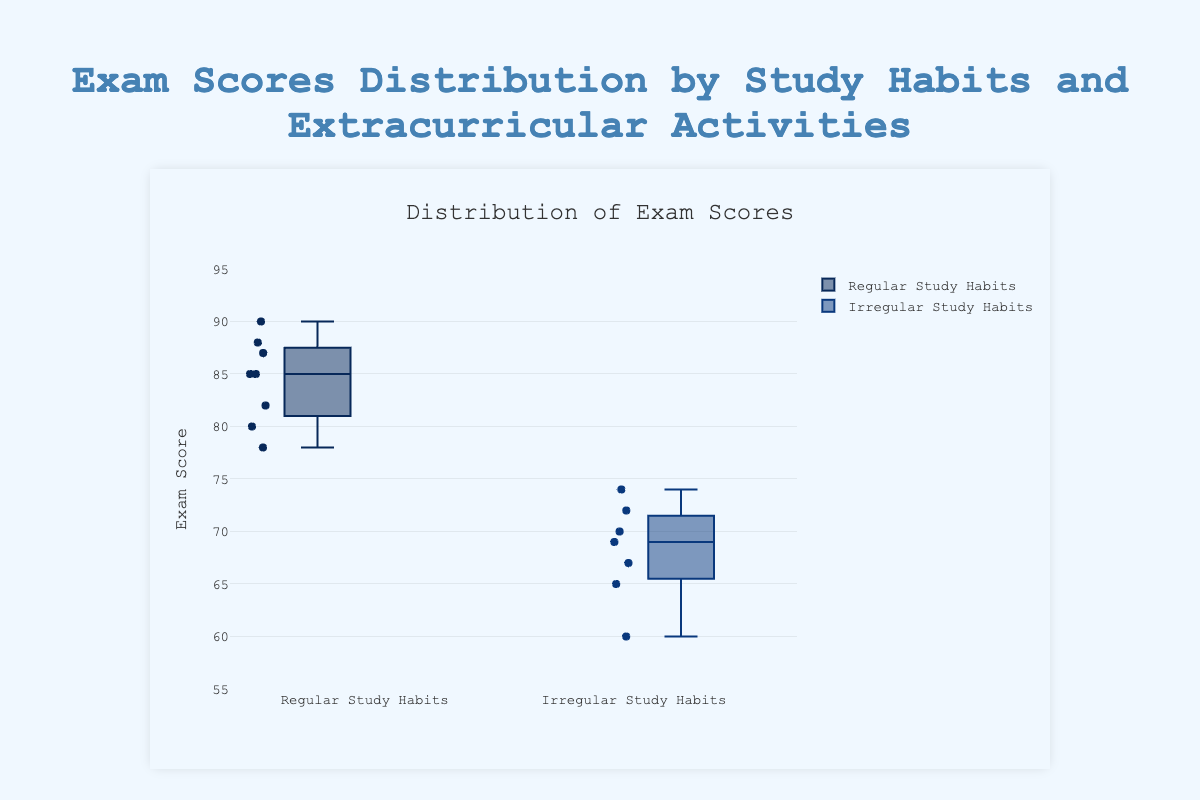What is the title of the box plot? The title is located at the top center of the plot and provides a summary description of what the box plot represents. Here, it reads "Distribution of Exam Scores."
Answer: Distribution of Exam Scores What are the categories on the x-axis? The x-axis categories are the levels of the grouping variable, which in this case are the two types of study habits: "Regular Study Habits" and "Irregular Study Habits."
Answer: Regular Study Habits, Irregular Study Habits What is the range of exam scores represented on the y-axis? The y-axis shows a numerical range indicating exam scores. It spans from approximately 55 to 95, as outlined by the axis labels and tick marks within this interval.
Answer: 55 to 95 Which study habit category has the higher median score? The median score for each category is marked by the line inside the box. By comparing the median lines within the boxes for both categories, the median for "Regular Study Habits" is higher than "Irregular Study Habits."
Answer: Regular Study Habits What is the interquartile range (IQR) for students with irregular study habits? The IQR is the length of the box, which spans from the first quartile (Q1) to the third quartile (Q3). For "Irregular Study Habits," Q1 is around 65 and Q3 is around 74, so the IQR is 74 - 65.
Answer: 9 How many outliers are present in the "Regular Study Habits" category? Outliers are typically represented by individual points that lie outside the whiskers of the box plot. For "Regular Study Habits," counting these points gives you the number of outliers.
Answer: 0 Which group has the maximum exam score, and what is it? The maximum exam score can be found at the upper end of the whisker for each box. Comparing the upper whiskers, the "Regular Study Habits" has the highest point at approximately 90.
Answer: Regular Study Habits, 90 Are there more students scoring below 70 in the "Irregular Study Habits" or "Regular Study Habits" group? By visually inspecting the lower regions of each box plot, more points are visible below the 70 mark for "Irregular Study Habits" compared to "Regular Study Habits," which indicates more students in this range.
Answer: Irregular Study Habits What is the difference between the median scores of the two study habit categories? The median scores are the lines inside the boxes. For "Regular Study Habits," the median is around 85, and for "Irregular Study Habits," it is around 70. The difference is 85 - 70.
Answer: 15 How does the overall spread of scores compare between regular and irregular study habits? The overall spread encompasses the range from the minimum to the maximum score in each category. "Regular Study Habits" has a higher maximum and lower spread within the box compared to "Irregular Study Habits." This suggests better performance and consistency.
Answer: Regular Study Habits show higher consistency in scores 